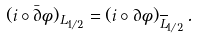Convert formula to latex. <formula><loc_0><loc_0><loc_500><loc_500>( i \circ \bar { \partial } \phi ) _ { L _ { 1 / 2 } } = ( i \circ \partial \phi ) _ { \overline { L } _ { 1 / 2 } } \, .</formula> 